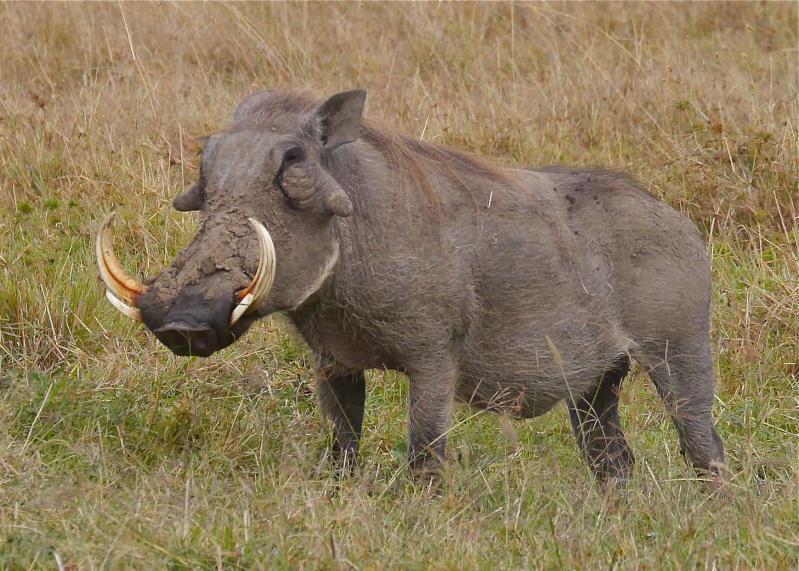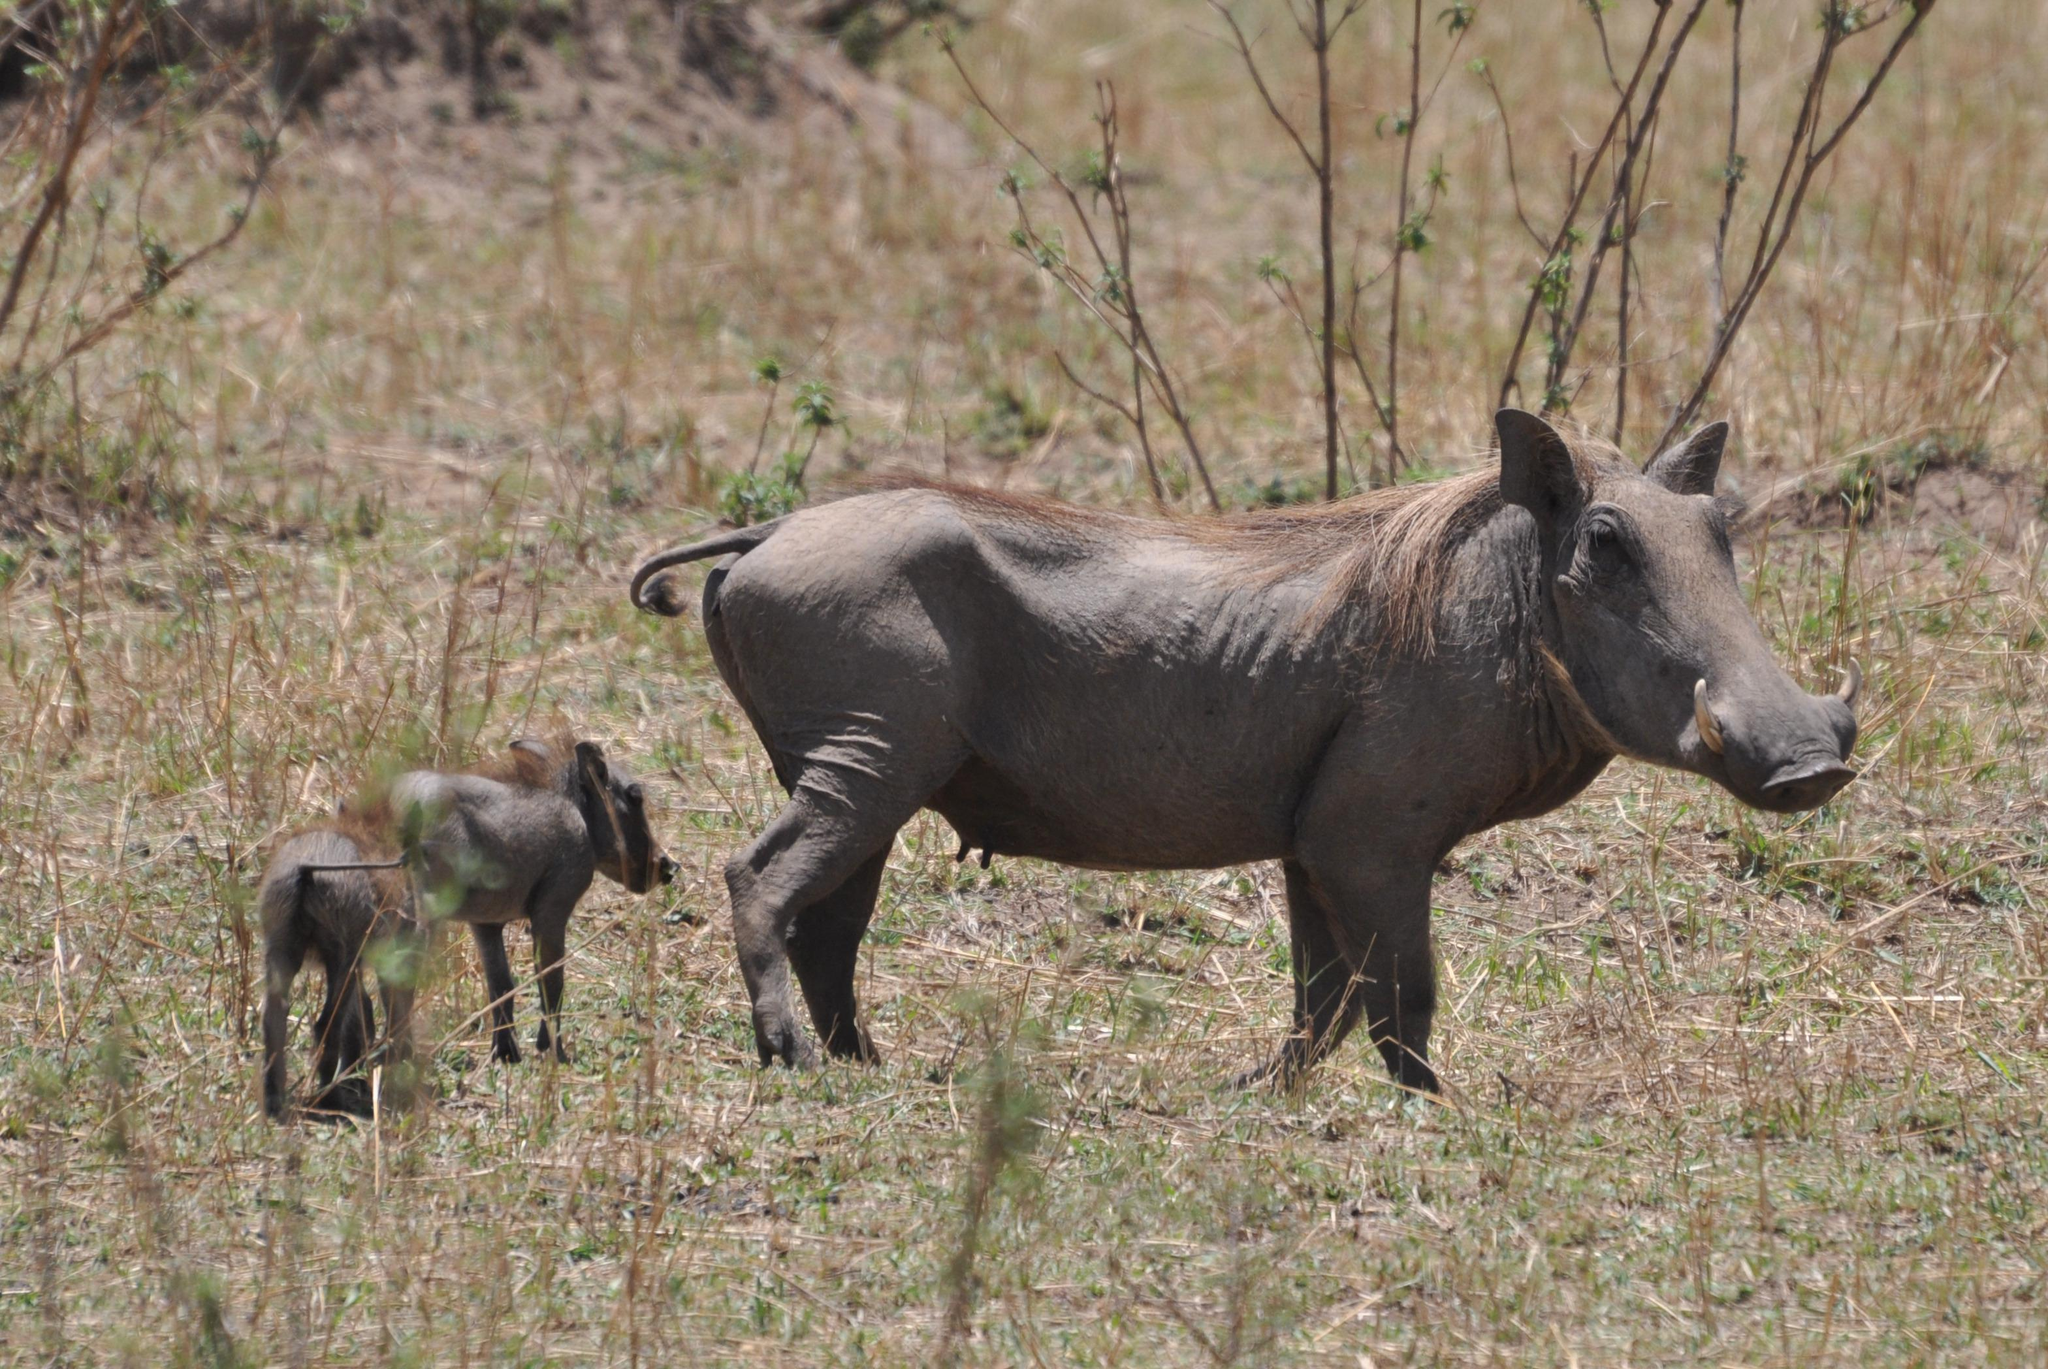The first image is the image on the left, the second image is the image on the right. Given the left and right images, does the statement "There are two hogs facing left." hold true? Answer yes or no. No. 